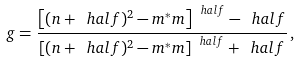<formula> <loc_0><loc_0><loc_500><loc_500>g = \frac { \left [ ( n + \ h a l f ) ^ { 2 } - m ^ { * } m \right ] ^ { \ h a l f } - \ h a l f } { \left [ ( n + \ h a l f ) ^ { 2 } - m ^ { * } m \right ] ^ { \ h a l f } + \ h a l f } \, ,</formula> 